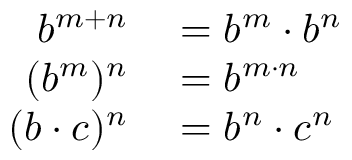Convert formula to latex. <formula><loc_0><loc_0><loc_500><loc_500>\begin{array} { r l } { b ^ { m + n } } & = b ^ { m } \cdot b ^ { n } } \\ { ( b ^ { m } ) ^ { n } } & = b ^ { m \cdot n } } \\ { ( b \cdot c ) ^ { n } } & = b ^ { n } \cdot c ^ { n } } \end{array}</formula> 